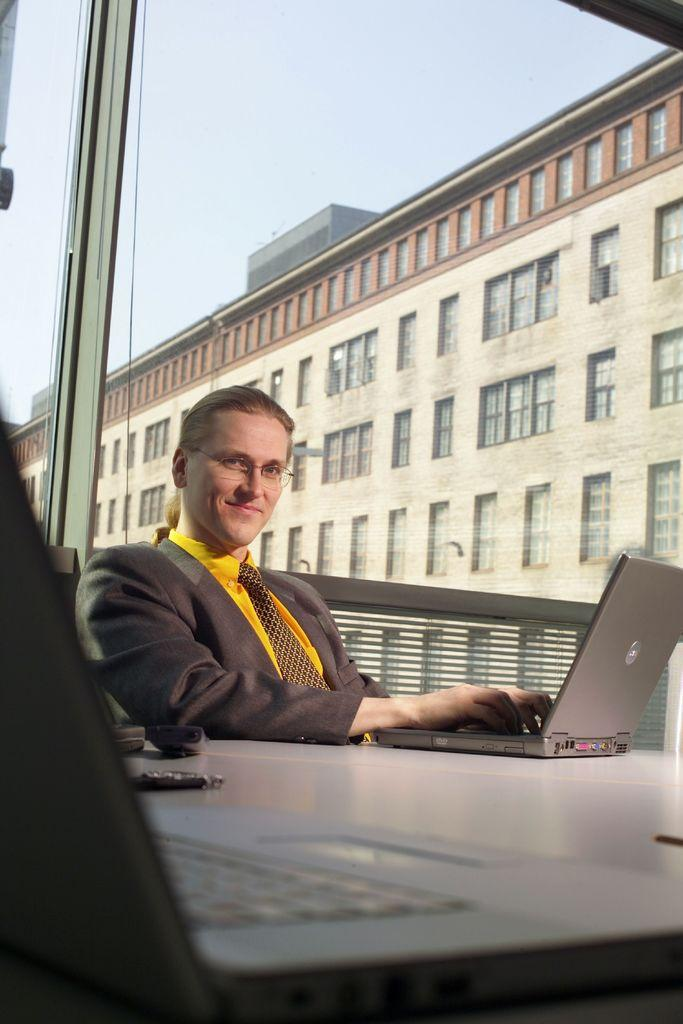Who is present in the image? There is a woman in the image. What is the woman's expression? The woman is smiling. What is on the table in the image? There are laptops and other objects on the table. Can you describe the background of the image? There is a building and the sky visible in the background of the image. What type of toothbrush is the woman using in the image? There is no toothbrush present in the image. What experience has the woman had that is depicted in the image? The image does not depict any specific experience or event in the woman's life. 